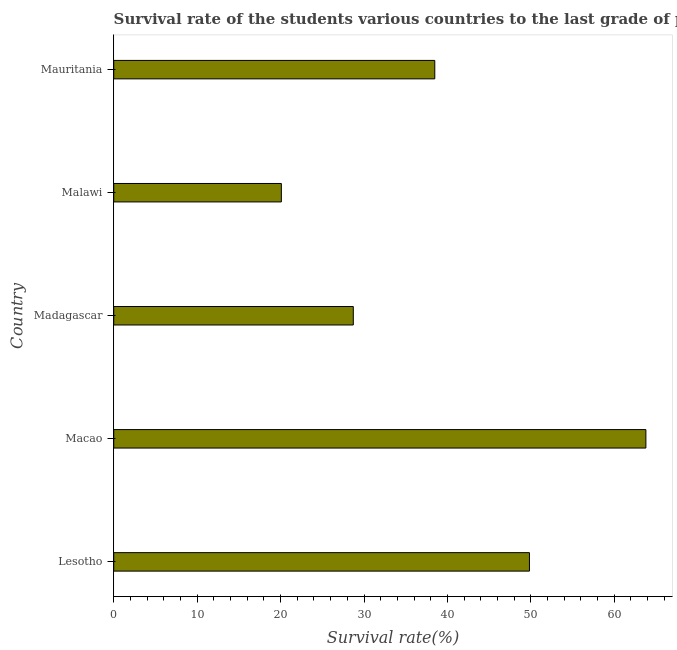Does the graph contain any zero values?
Your answer should be compact. No. What is the title of the graph?
Give a very brief answer. Survival rate of the students various countries to the last grade of primary education. What is the label or title of the X-axis?
Your answer should be compact. Survival rate(%). What is the survival rate in primary education in Mauritania?
Your answer should be very brief. 38.48. Across all countries, what is the maximum survival rate in primary education?
Ensure brevity in your answer.  63.79. Across all countries, what is the minimum survival rate in primary education?
Your answer should be compact. 20.09. In which country was the survival rate in primary education maximum?
Provide a short and direct response. Macao. In which country was the survival rate in primary education minimum?
Keep it short and to the point. Malawi. What is the sum of the survival rate in primary education?
Give a very brief answer. 200.92. What is the difference between the survival rate in primary education in Lesotho and Malawi?
Provide a succinct answer. 29.74. What is the average survival rate in primary education per country?
Ensure brevity in your answer.  40.18. What is the median survival rate in primary education?
Ensure brevity in your answer.  38.48. What is the ratio of the survival rate in primary education in Madagascar to that in Mauritania?
Keep it short and to the point. 0.75. What is the difference between the highest and the second highest survival rate in primary education?
Your answer should be compact. 13.96. Is the sum of the survival rate in primary education in Lesotho and Madagascar greater than the maximum survival rate in primary education across all countries?
Give a very brief answer. Yes. What is the difference between the highest and the lowest survival rate in primary education?
Your response must be concise. 43.7. In how many countries, is the survival rate in primary education greater than the average survival rate in primary education taken over all countries?
Offer a very short reply. 2. Are all the bars in the graph horizontal?
Ensure brevity in your answer.  Yes. What is the Survival rate(%) in Lesotho?
Your answer should be very brief. 49.83. What is the Survival rate(%) of Macao?
Give a very brief answer. 63.79. What is the Survival rate(%) in Madagascar?
Provide a short and direct response. 28.72. What is the Survival rate(%) in Malawi?
Ensure brevity in your answer.  20.09. What is the Survival rate(%) of Mauritania?
Your answer should be very brief. 38.48. What is the difference between the Survival rate(%) in Lesotho and Macao?
Offer a very short reply. -13.96. What is the difference between the Survival rate(%) in Lesotho and Madagascar?
Offer a very short reply. 21.12. What is the difference between the Survival rate(%) in Lesotho and Malawi?
Give a very brief answer. 29.74. What is the difference between the Survival rate(%) in Lesotho and Mauritania?
Provide a succinct answer. 11.35. What is the difference between the Survival rate(%) in Macao and Madagascar?
Your answer should be compact. 35.07. What is the difference between the Survival rate(%) in Macao and Malawi?
Offer a very short reply. 43.7. What is the difference between the Survival rate(%) in Macao and Mauritania?
Provide a short and direct response. 25.31. What is the difference between the Survival rate(%) in Madagascar and Malawi?
Provide a succinct answer. 8.62. What is the difference between the Survival rate(%) in Madagascar and Mauritania?
Provide a short and direct response. -9.77. What is the difference between the Survival rate(%) in Malawi and Mauritania?
Give a very brief answer. -18.39. What is the ratio of the Survival rate(%) in Lesotho to that in Macao?
Offer a very short reply. 0.78. What is the ratio of the Survival rate(%) in Lesotho to that in Madagascar?
Make the answer very short. 1.74. What is the ratio of the Survival rate(%) in Lesotho to that in Malawi?
Offer a very short reply. 2.48. What is the ratio of the Survival rate(%) in Lesotho to that in Mauritania?
Keep it short and to the point. 1.29. What is the ratio of the Survival rate(%) in Macao to that in Madagascar?
Offer a terse response. 2.22. What is the ratio of the Survival rate(%) in Macao to that in Malawi?
Offer a terse response. 3.17. What is the ratio of the Survival rate(%) in Macao to that in Mauritania?
Keep it short and to the point. 1.66. What is the ratio of the Survival rate(%) in Madagascar to that in Malawi?
Provide a short and direct response. 1.43. What is the ratio of the Survival rate(%) in Madagascar to that in Mauritania?
Provide a short and direct response. 0.75. What is the ratio of the Survival rate(%) in Malawi to that in Mauritania?
Make the answer very short. 0.52. 